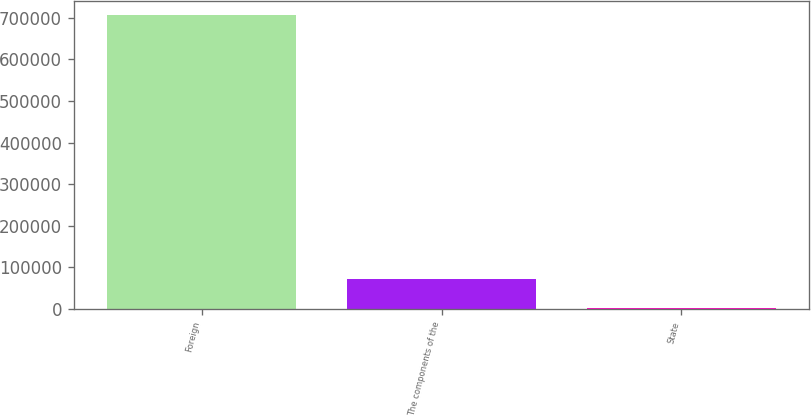Convert chart. <chart><loc_0><loc_0><loc_500><loc_500><bar_chart><fcel>Foreign<fcel>The components of the<fcel>State<nl><fcel>705628<fcel>72171.1<fcel>1787<nl></chart> 